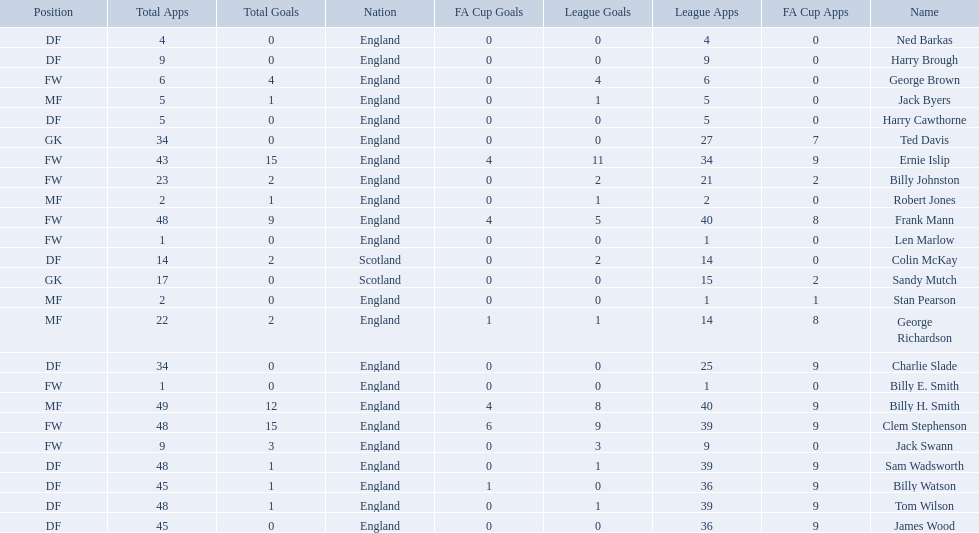What is the average number of scotland's total apps? 15.5. 